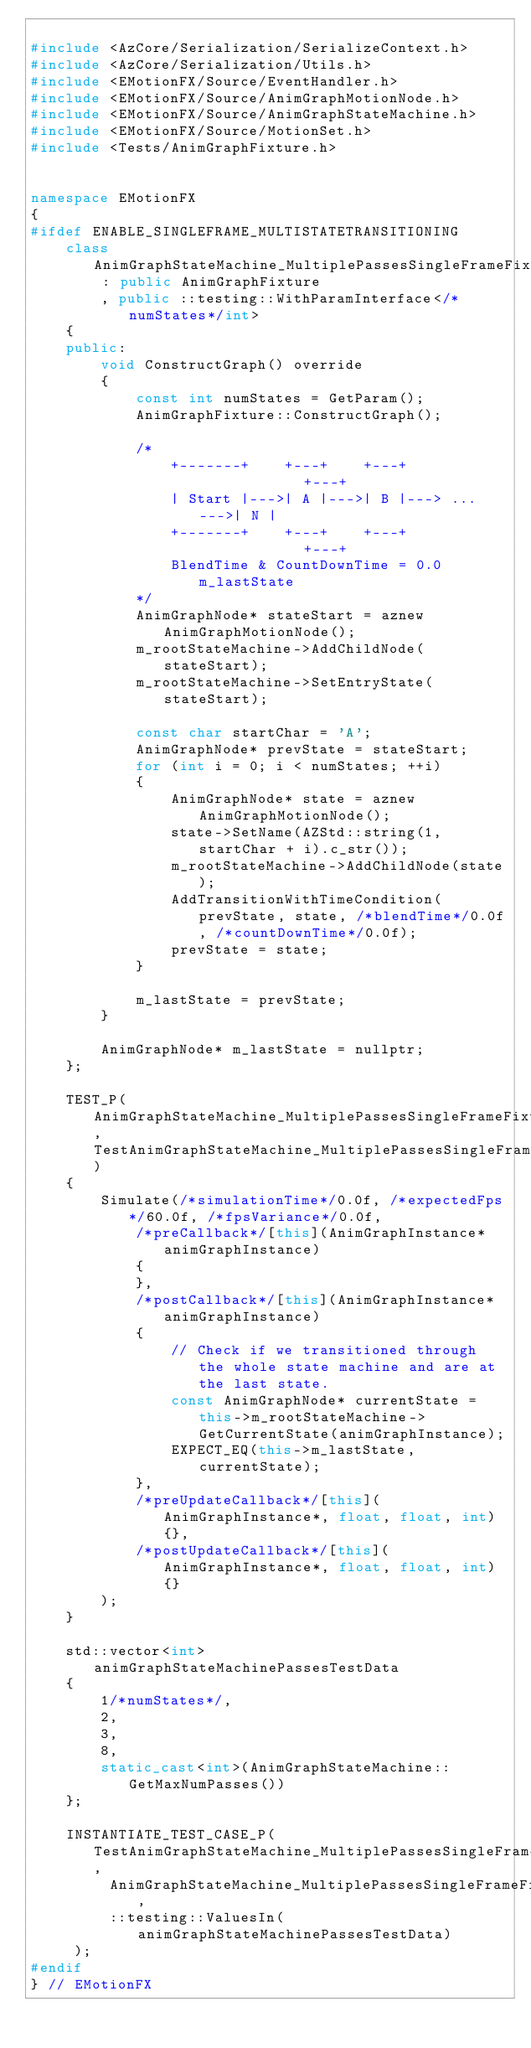Convert code to text. <code><loc_0><loc_0><loc_500><loc_500><_C++_>
#include <AzCore/Serialization/SerializeContext.h>
#include <AzCore/Serialization/Utils.h>
#include <EMotionFX/Source/EventHandler.h>
#include <EMotionFX/Source/AnimGraphMotionNode.h>
#include <EMotionFX/Source/AnimGraphStateMachine.h>
#include <EMotionFX/Source/MotionSet.h>
#include <Tests/AnimGraphFixture.h>


namespace EMotionFX
{
#ifdef ENABLE_SINGLEFRAME_MULTISTATETRANSITIONING
    class AnimGraphStateMachine_MultiplePassesSingleFrameFixture : public AnimGraphFixture
        , public ::testing::WithParamInterface</*numStates*/int>
    {
    public:
        void ConstructGraph() override
        {
            const int numStates = GetParam();
            AnimGraphFixture::ConstructGraph();

            /*
                +-------+    +---+    +---+             +---+
                | Start |--->| A |--->| B |---> ... --->| N |
                +-------+    +---+    +---+             +---+
                BlendTime & CountDownTime = 0.0      m_lastState
            */
            AnimGraphNode* stateStart = aznew AnimGraphMotionNode();
            m_rootStateMachine->AddChildNode(stateStart);
            m_rootStateMachine->SetEntryState(stateStart);

            const char startChar = 'A';
            AnimGraphNode* prevState = stateStart;
            for (int i = 0; i < numStates; ++i)
            {
                AnimGraphNode* state = aznew AnimGraphMotionNode();
                state->SetName(AZStd::string(1, startChar + i).c_str());
                m_rootStateMachine->AddChildNode(state);
                AddTransitionWithTimeCondition(prevState, state, /*blendTime*/0.0f, /*countDownTime*/0.0f);
                prevState = state;
            }

            m_lastState = prevState;
        }

        AnimGraphNode* m_lastState = nullptr;
    };

    TEST_P(AnimGraphStateMachine_MultiplePassesSingleFrameFixture, TestAnimGraphStateMachine_MultiplePassesSingleFrameTest)
    {
        Simulate(/*simulationTime*/0.0f, /*expectedFps*/60.0f, /*fpsVariance*/0.0f,
            /*preCallback*/[this](AnimGraphInstance* animGraphInstance)
            {
            },
            /*postCallback*/[this](AnimGraphInstance* animGraphInstance)
            {
                // Check if we transitioned through the whole state machine and are at the last state.
                const AnimGraphNode* currentState = this->m_rootStateMachine->GetCurrentState(animGraphInstance);
                EXPECT_EQ(this->m_lastState, currentState);
            },
            /*preUpdateCallback*/[this](AnimGraphInstance*, float, float, int) {},
            /*postUpdateCallback*/[this](AnimGraphInstance*, float, float, int) {}
        );
    }

    std::vector<int> animGraphStateMachinePassesTestData
    {
        1/*numStates*/,
        2,
        3,
        8,
        static_cast<int>(AnimGraphStateMachine::GetMaxNumPasses())
    };

    INSTANTIATE_TEST_CASE_P(TestAnimGraphStateMachine_MultiplePassesSingleFrameTest,
         AnimGraphStateMachine_MultiplePassesSingleFrameFixture,
         ::testing::ValuesIn(animGraphStateMachinePassesTestData)
     );
#endif
} // EMotionFX
</code> 